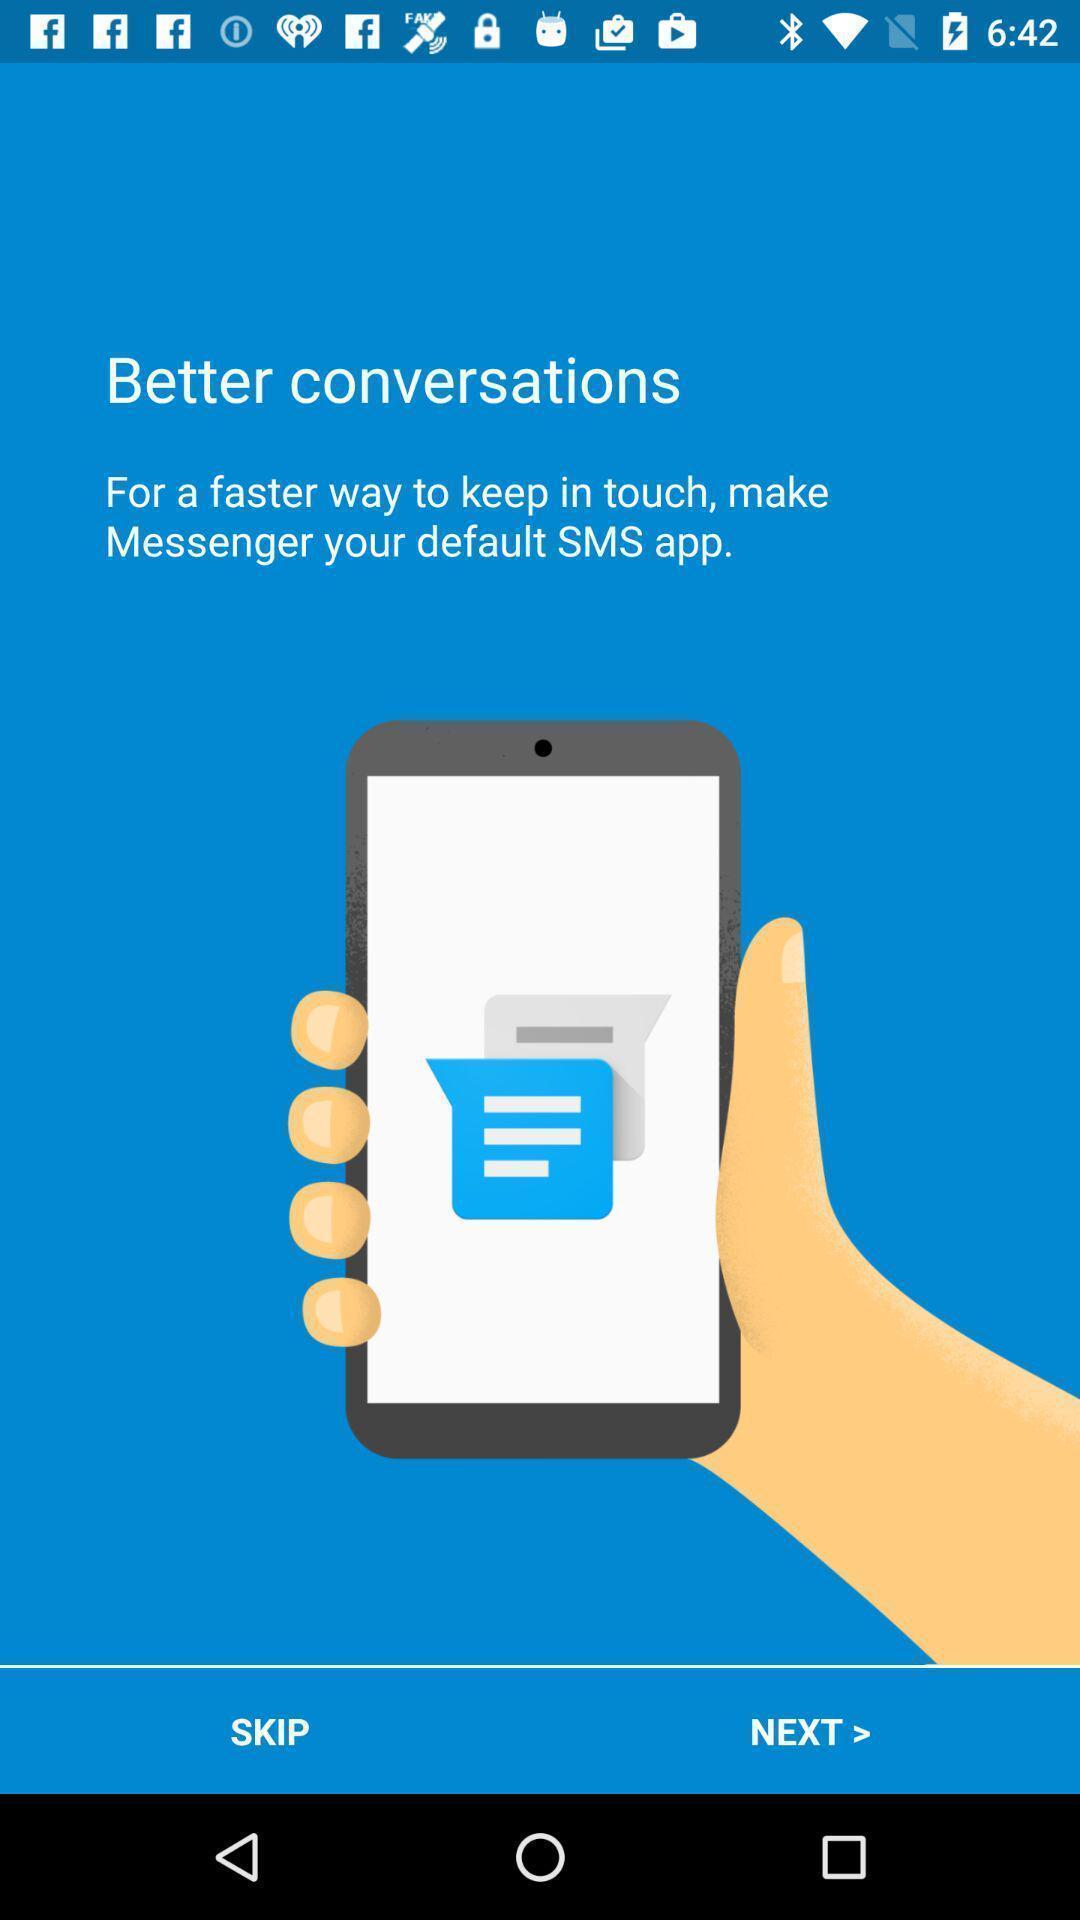Tell me about the visual elements in this screen capture. Welcome page with skip and next options in social application. 